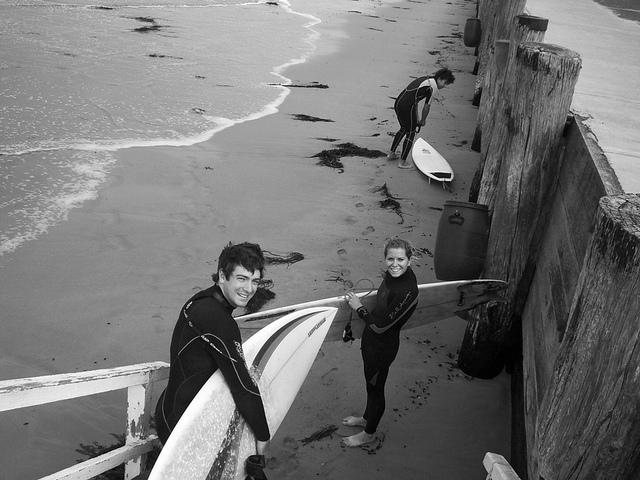Are these people smiling?
Be succinct. Yes. What are the two boys doing?
Keep it brief. Surfing. Why are the people wearing wetsuits?
Answer briefly. Surfing. Are there people in the picture?
Answer briefly. Yes. What are they holding?
Concise answer only. Surfboards. What are these people looking at?
Quick response, please. Camera. Are these children on a boat?
Be succinct. No. 